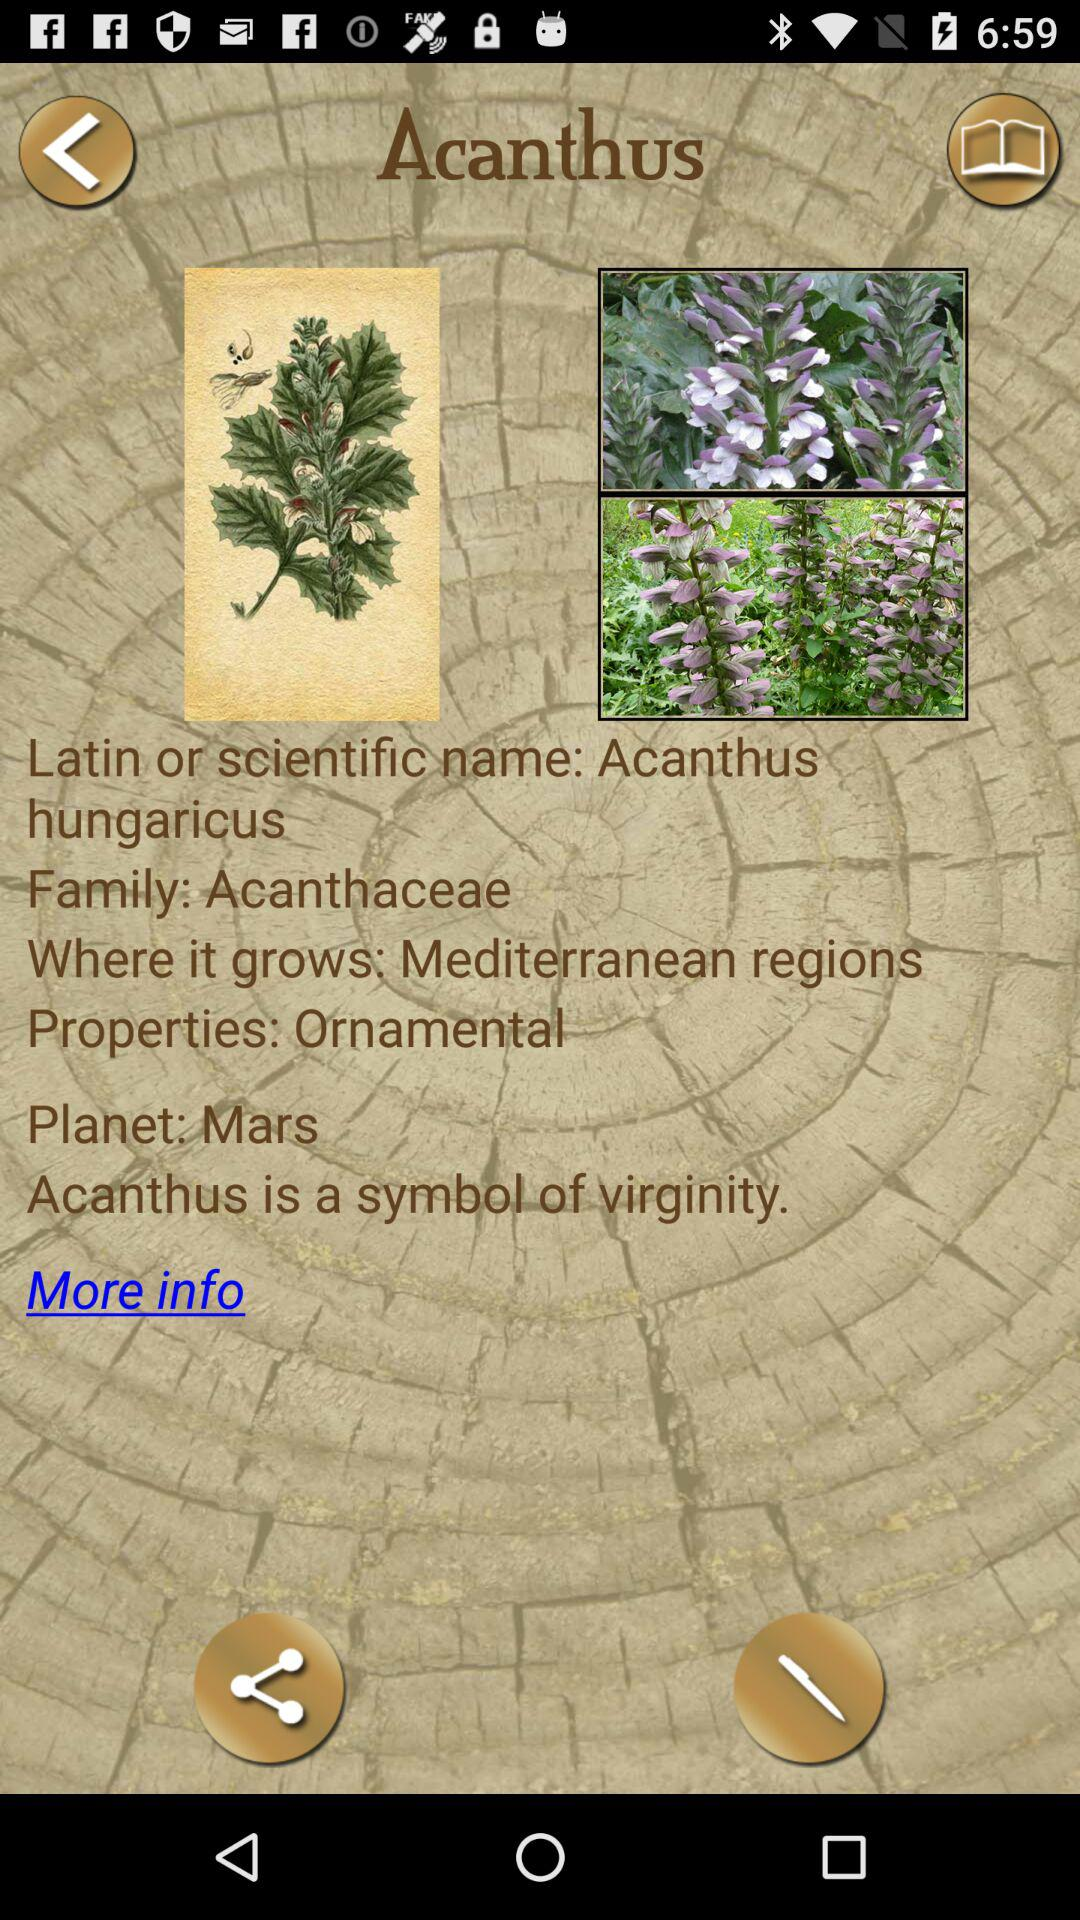What is the scientific name of Acanthus? The scientific name is Acanthus hungaricus. 